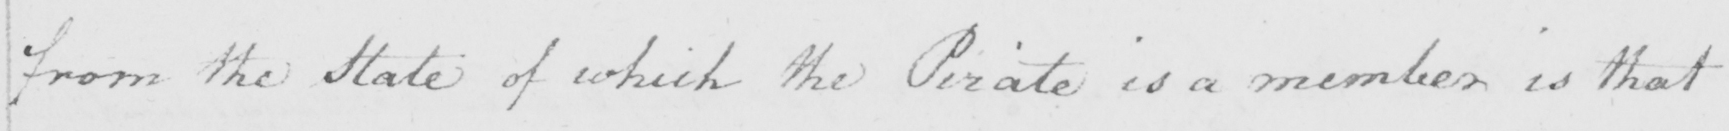Transcribe the text shown in this historical manuscript line. from the State of which the Pirate is a member is that 